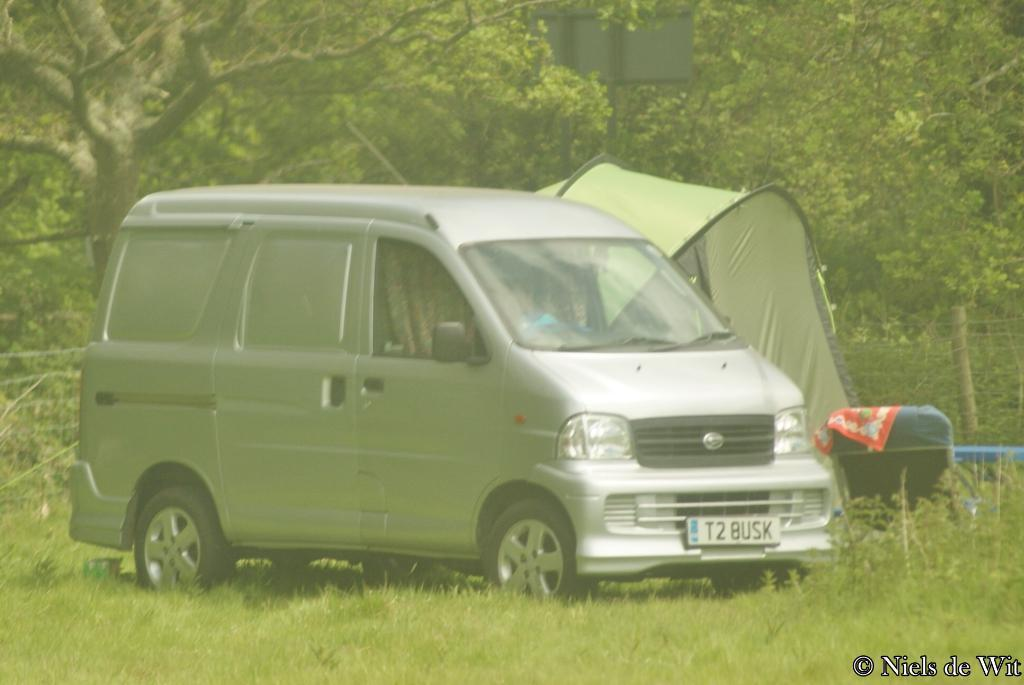Provide a one-sentence caption for the provided image. A silver van says T2 BUSK on the front license plate. 